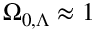Convert formula to latex. <formula><loc_0><loc_0><loc_500><loc_500>\Omega _ { 0 , \Lambda } \approx 1</formula> 